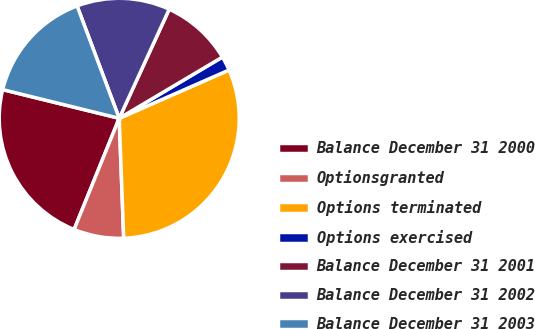<chart> <loc_0><loc_0><loc_500><loc_500><pie_chart><fcel>Balance December 31 2000<fcel>Optionsgranted<fcel>Options terminated<fcel>Options exercised<fcel>Balance December 31 2001<fcel>Balance December 31 2002<fcel>Balance December 31 2003<nl><fcel>22.71%<fcel>6.73%<fcel>31.0%<fcel>1.93%<fcel>9.64%<fcel>12.55%<fcel>15.45%<nl></chart> 